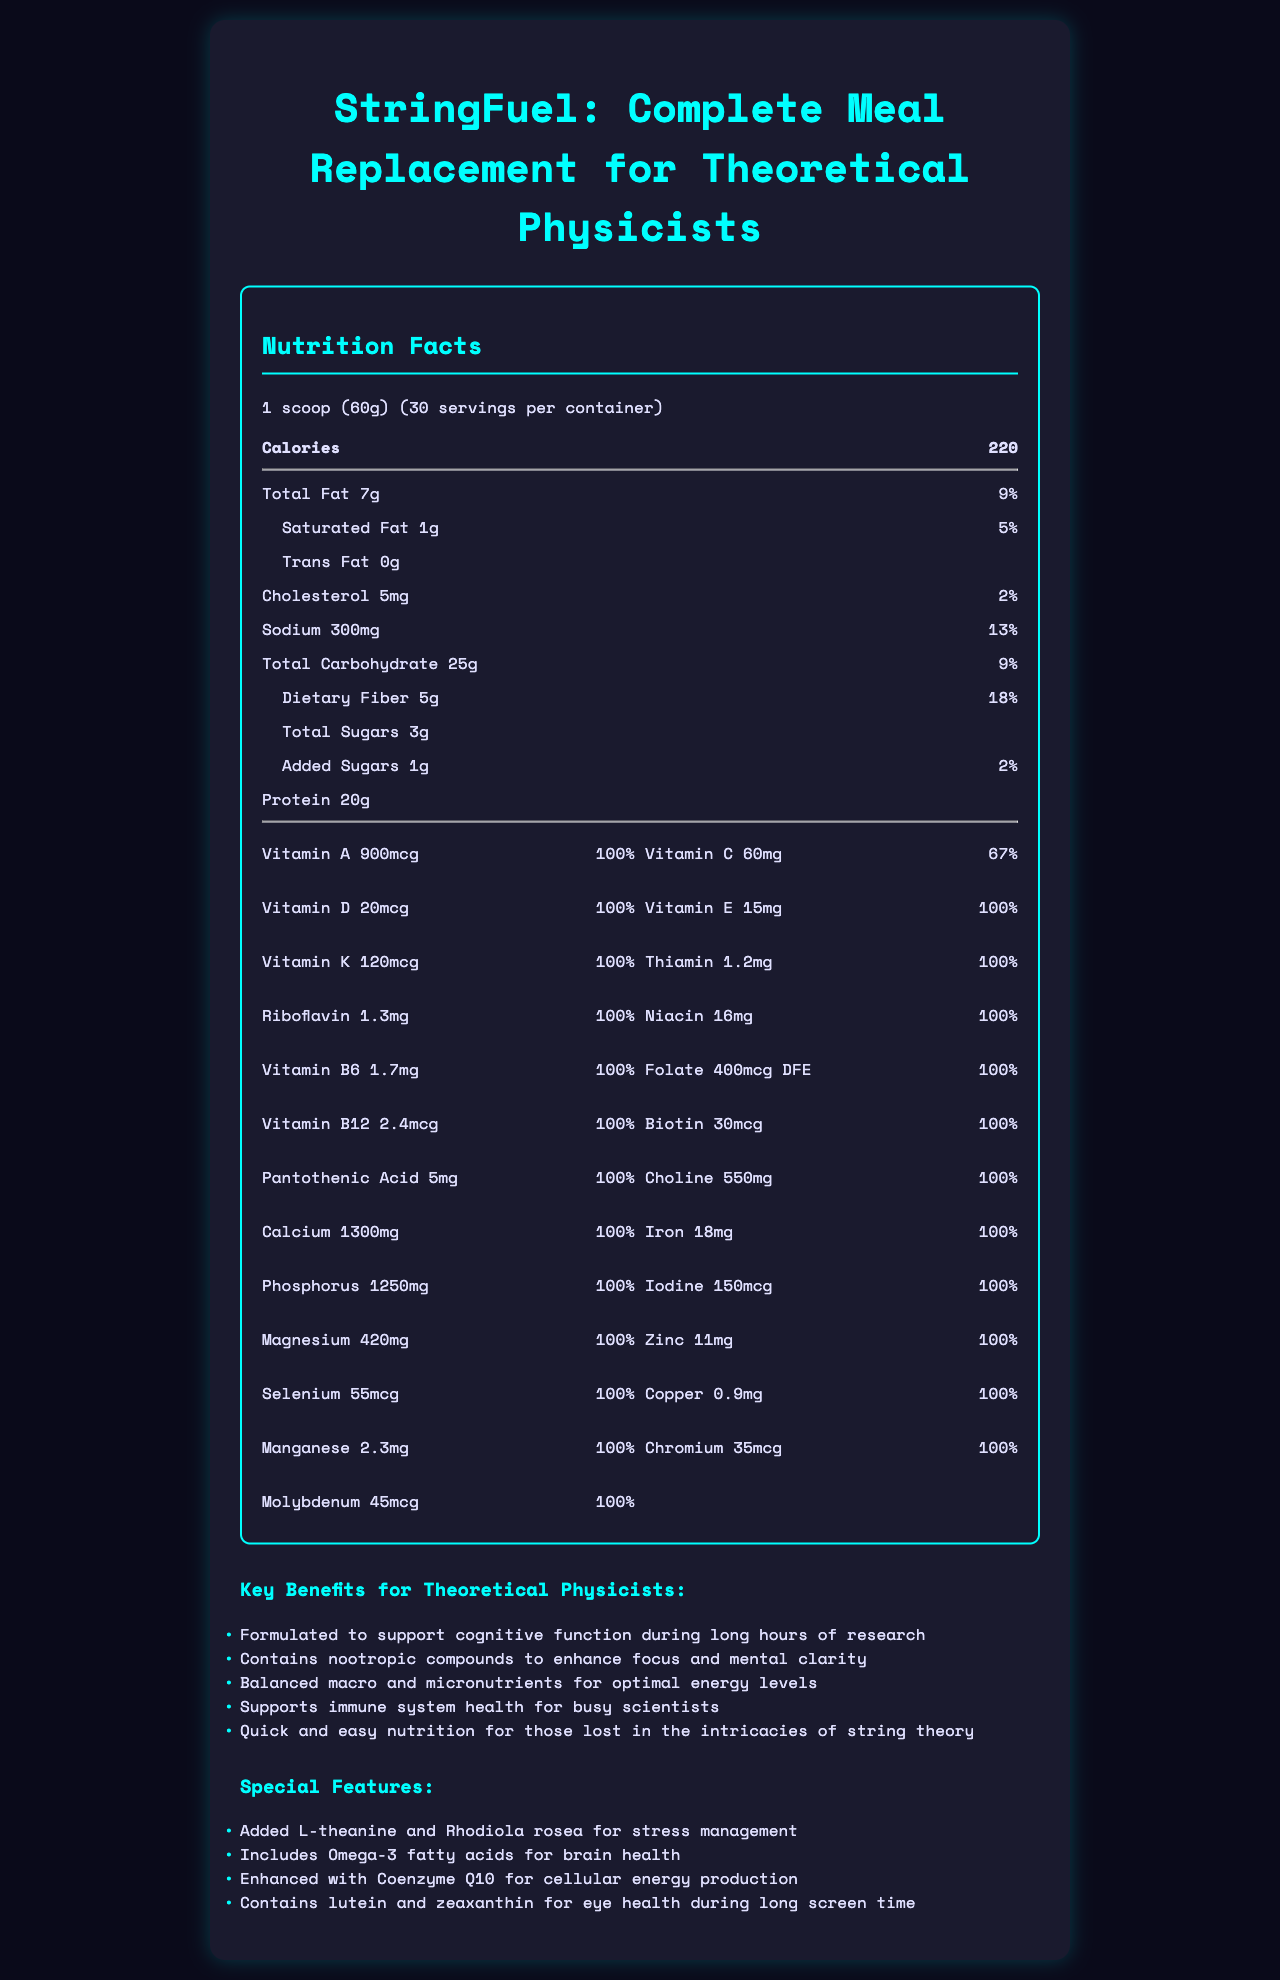what is the serving size? The serving size is directly listed as "1 scoop (60g)" near the top of the nutrition facts section.
Answer: 1 scoop (60g) how many servings per container are there? The number of servings per container is listed as "30" near the top of the nutrition facts section.
Answer: 30 what is the total amount of dietary fiber in one serving? The total amount of dietary fiber is listed as "5g" in the nutrition facts.
Answer: 5g what percent of the daily value for sodium does one serving provide? The daily value for sodium is listed as "13%" next to the amount of sodium in the nutrition facts.
Answer: 13% which vitamin has the highest amount per serving? A. Vitamin D B. Vitamin E C. Vitamin C D. Vitamin B12 Vitamin D has the highest amount per serving at 20mcg, which is 100% daily value, while the amounts of Vitamins E, C, and B12 are 15mg, 60mg, 2.4mcg respectively.
Answer: A is there any cholesterol in the meal replacement shake? The nutrition facts list cholesterol as "5mg" with a daily value of "2%".
Answer: Yes what is the main protein source in this meal replacement shake? The ingredients list "Pea Protein Isolate" as the first ingredient, indicating it is the main protein source.
Answer: Pea Protein Isolate how much calcium does one serving provide? The nutrition facts show that one serving provides "1300mg" of calcium, which is 100% of the daily value.
Answer: 1300mg what kind of fatty acids are included for brain health? The special features section lists "Includes Omega-3 fatty acids for brain health".
Answer: Omega-3 fatty acids which ingredient is included to help with stress management? The special features section lists "Added L-theanine and Rhodiola rosea for stress management".
Answer: L-theanine and Rhodiola rosea how many grams of protein are there in one serving of this shake? The nutrition facts list "Protein 20g".
Answer: 20g what is the main purpose of this meal replacement shake for scientists? The marketing claims highlight support for cognitive function, focus, energy levels, immune system health, and quick nutrition for busy scientists.
Answer: Support cognitive function and overall health what is the percentage of daily value for iron in one serving? The nutrition facts list "Iron 18mg" with a daily value of "100%".
Answer: 100% does this product contain soy? The allergen information states it is manufactured in a facility that processes soy, but it does not specify if soy is included in the product.
Answer: Cannot be determined what is the name of the meal replacement shake? The document title and the top of the nutrition label state the product name as "StringFuel: Complete Meal Replacement for Theoretical Physicists".
Answer: StringFuel: Complete Meal Replacement for Theoretical Physicists how much sugar is there in one serving? A. 0g B. 1g C. 3g D. 5g The nutrition facts list "Total Sugars 3g".
Answer: C which of the following vitamins are at 100% daily value per serving? I. Vitamin A II. Vitamin C III. Vitamin E IV. Vitamin B6 Vitamins with 100% daily value are Vitamin A, Vitamin E, and Vitamin B6, but not Vitamin C which is 67%.
Answer: I, III, IV describe the main contents of the document The document includes nutrition facts, a list of ingredients, allergen information, marketing claims, and special features of the product "StringFuel."
Answer: Nutrition Facts, Ingredients, and Benefits of StringFuel how much cholesterol is in one serving? The nutrition facts list "Cholesterol 5mg."
Answer: 5mg what is the total fat content? The nutrition facts list "Total Fat 7g."
Answer: 7g what are the additional ingredients for stress management? A. Stevia Leaf Extract B. L-theanine and Rhodiola rosea C. Omega-3 fatty acids D. Coenzyme Q10 The special features section lists "Added L-theanine and Rhodiola rosea for stress management."
Answer: B 